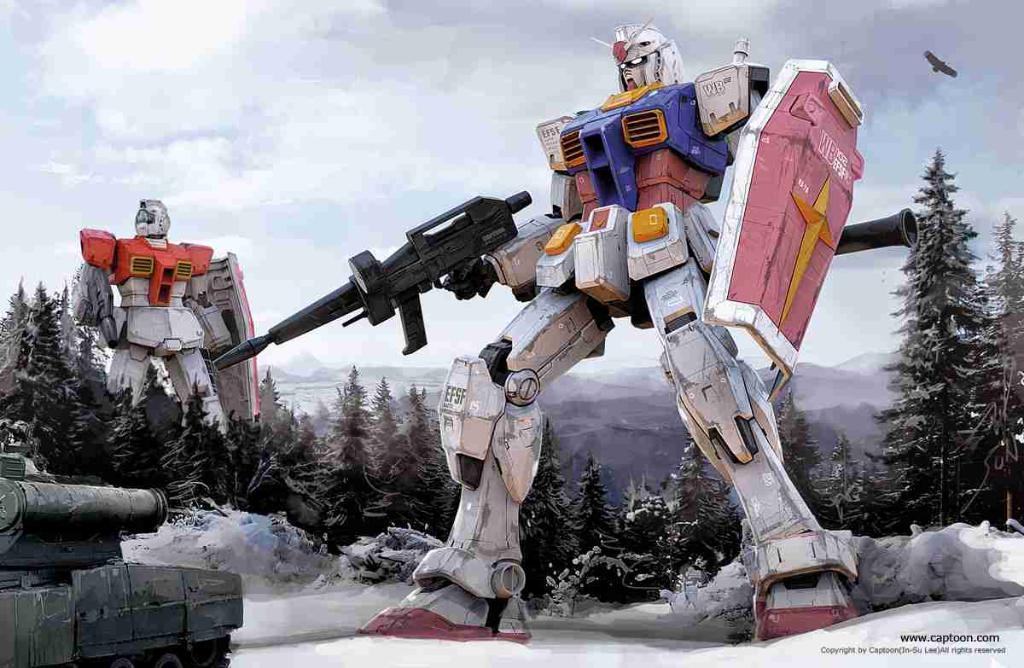Can you describe this image briefly? In this image we can see two robotic toys. Bottom left of the image tank is there. Behind the tank trees are present. The sky is covered with clouds. 